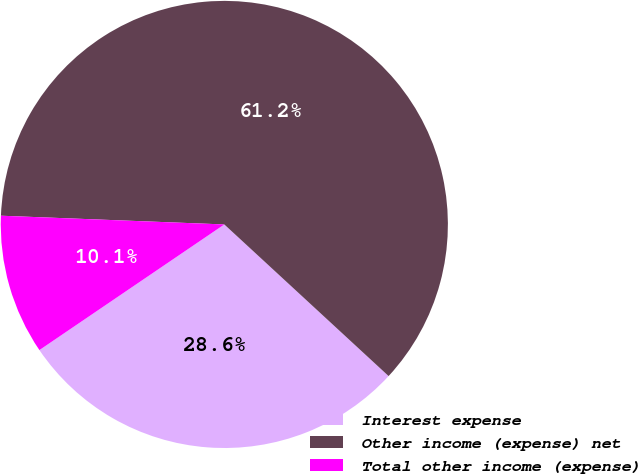Convert chart. <chart><loc_0><loc_0><loc_500><loc_500><pie_chart><fcel>Interest expense<fcel>Other income (expense) net<fcel>Total other income (expense)<nl><fcel>28.64%<fcel>61.24%<fcel>10.12%<nl></chart> 